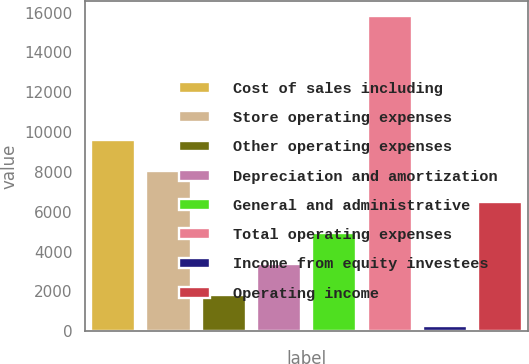<chart> <loc_0><loc_0><loc_500><loc_500><bar_chart><fcel>Cost of sales including<fcel>Store operating expenses<fcel>Other operating expenses<fcel>Depreciation and amortization<fcel>General and administrative<fcel>Total operating expenses<fcel>Income from equity investees<fcel>Operating income<nl><fcel>9586.92<fcel>8030.75<fcel>1806.07<fcel>3362.24<fcel>4918.41<fcel>15811.6<fcel>249.9<fcel>6474.58<nl></chart> 